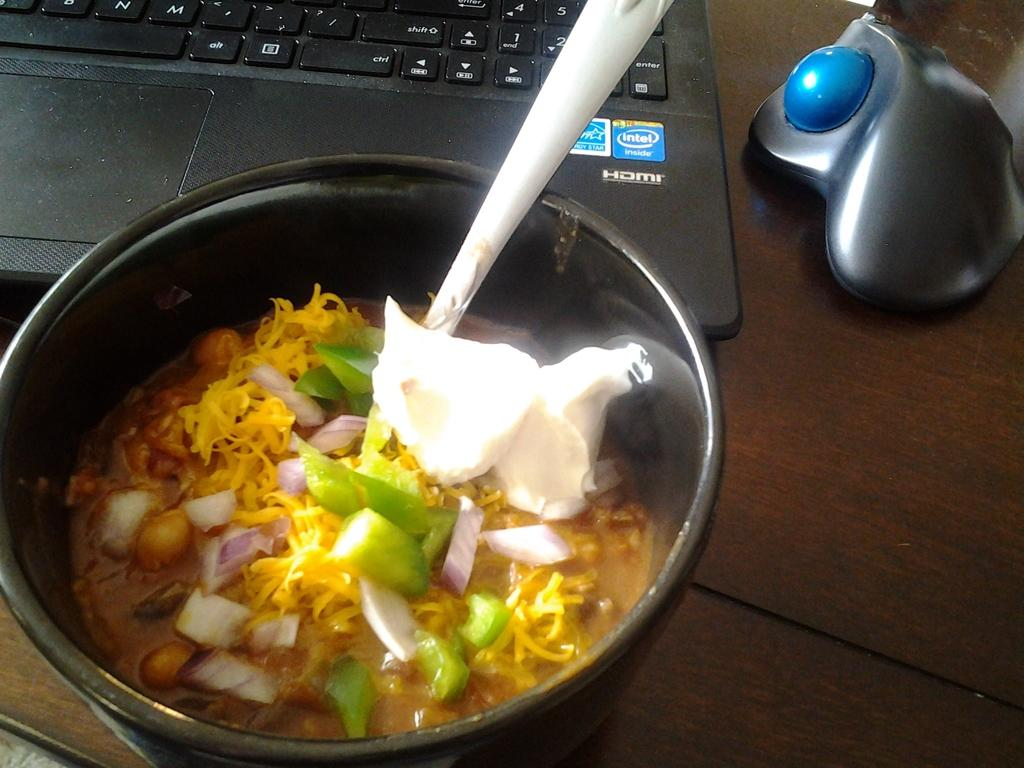What is the main piece of furniture in the image? There is a table in the image. What is placed on the table? There is a bowl and a laptop on the table. What is inside the bowl? There is food in the bowl. How might someone eat the food in the bowl? There is a spoon in the bowl, which can be used for eating. What is the unspecified object on the right side of the image? Unfortunately, the facts provided do not give any information about the object on the right side of the image. What type of prose can be heard being read from the back of the image? There is no indication of any reading or prose in the image, and the back of the image is not visible. 